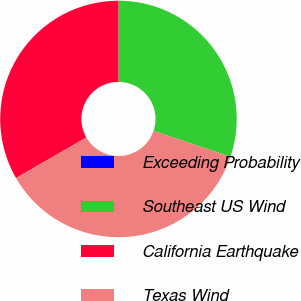Convert chart. <chart><loc_0><loc_0><loc_500><loc_500><pie_chart><fcel>Exceeding Probability<fcel>Southeast US Wind<fcel>California Earthquake<fcel>Texas Wind<nl><fcel>0.0%<fcel>30.18%<fcel>33.33%<fcel>36.49%<nl></chart> 